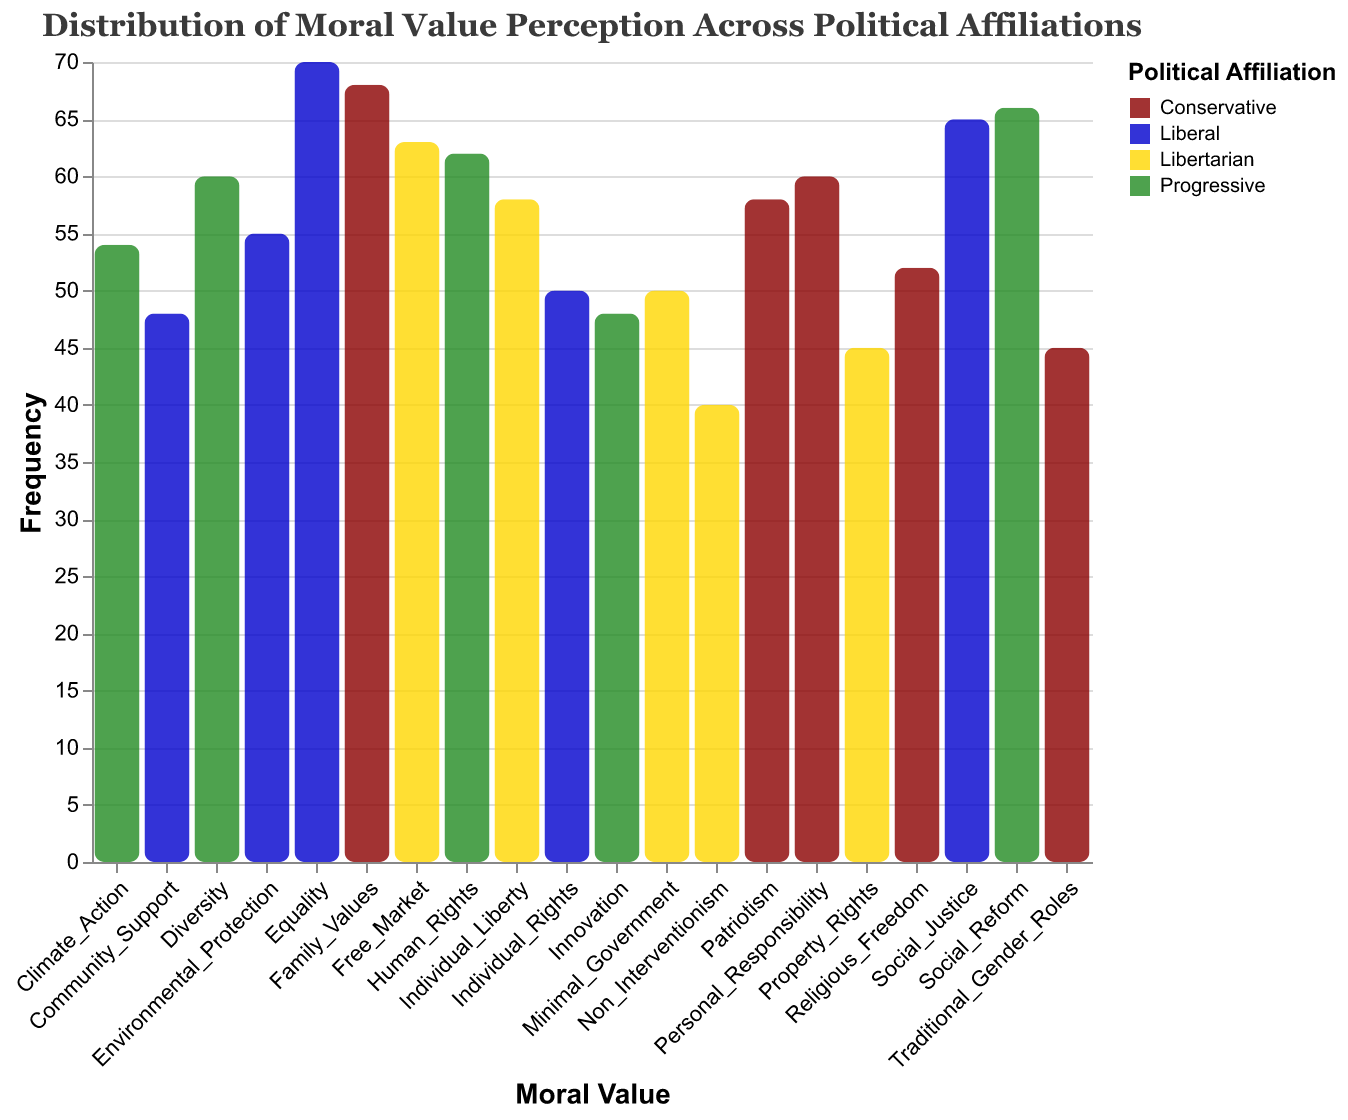What is the title of the plot? The title is located at the top of the plot and clearly describes the subject of the data.
Answer: Distribution of Moral Value Perception Across Political Affiliations Which moral value has the highest frequency for the Conservative affiliation? Looking at the bars colored for the Conservative affiliation, the one with the highest value represents Family Values.
Answer: Family Values Which political affiliation has the highest frequency for Equality? Locate the bar representing Equality and identify the color corresponding to the political affiliation.
Answer: Liberal What is the average frequency of moral values for the Libertarian affiliation? Sum the frequencies (63, 58, 50, 45, 40) and then divide by the number of values (5): (63 + 58 + 50 + 45 + 40) / 5.
Answer: 51.2 Which moral value has the smallest frequency across all political affiliations? Identify the bar with the lowest frequency value in the plot.
Answer: Non_Interventionism How does the frequency of Traditional Gender Roles in the Conservative affiliation compare to that of Innovation in the Progressive affiliation? Compare the heights of the bars representing Traditional Gender Roles for Conservatives and Innovation for Progressives.
Answer: Traditional Gender Roles > Innovation What is the total frequency of all moral values for the Liberal affiliation? Sum the frequencies of all values for the Liberal affiliation: (70 + 65 + 55 + 50 + 48).
Answer: 288 Identify the political affiliation with the lowest average frequency of moral values. Compute the average frequencies for each affiliation and compare: Conservative (56.6), Liberal (57.6), Libertarian (51.2), Progressive (58).
Answer: Libertarian Which political affiliation shows a higher frequency for Religious Freedom compared to Human Rights? Compare the frequencies for these values across the relevant affiliations (Religious Freedom is under Conservatives, Human Rights under Progressives).
Answer: Conservative 